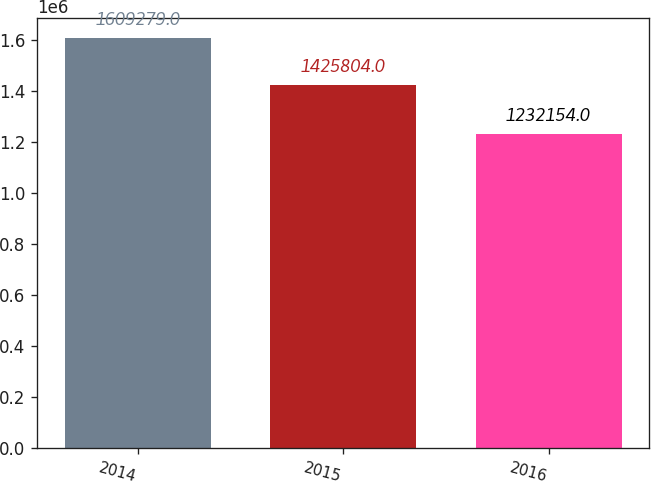Convert chart. <chart><loc_0><loc_0><loc_500><loc_500><bar_chart><fcel>2014<fcel>2015<fcel>2016<nl><fcel>1.60928e+06<fcel>1.4258e+06<fcel>1.23215e+06<nl></chart> 